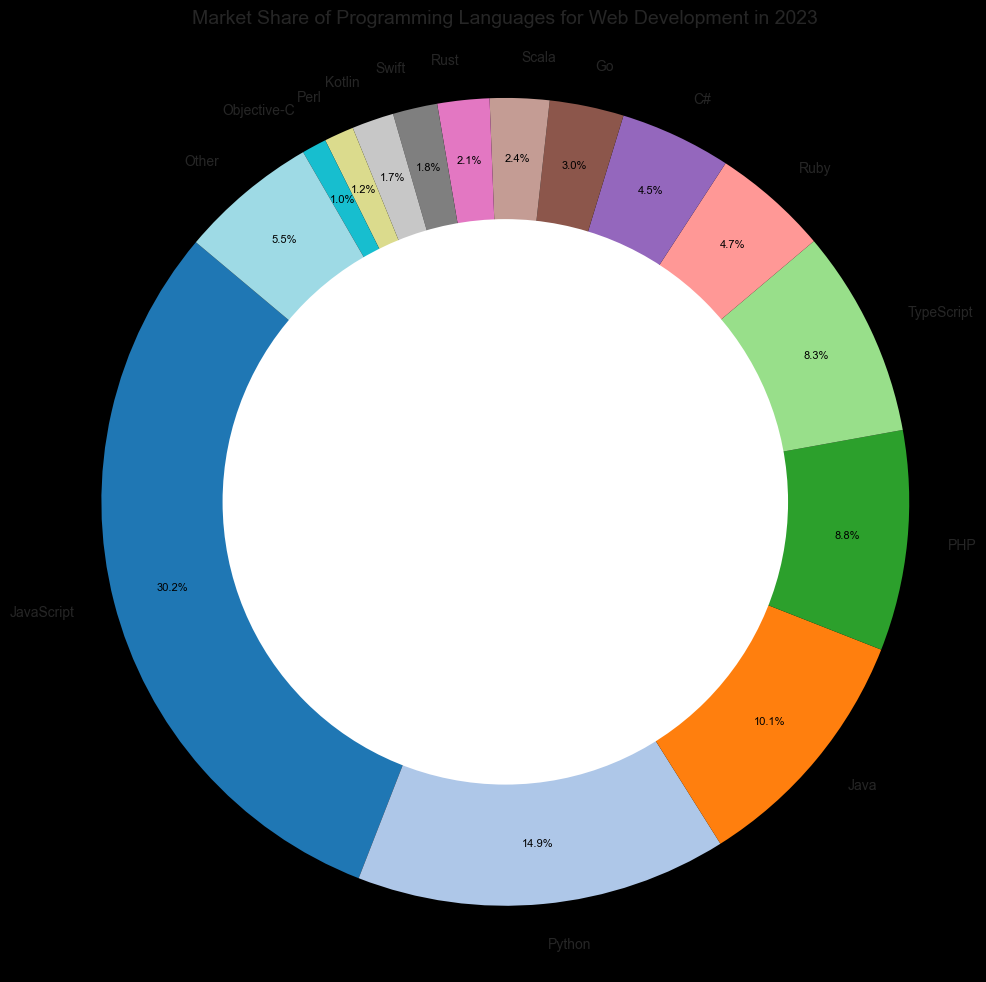What's the total market share of the top three programming languages? The top three programming languages by market share are JavaScript, Python, and Java. Summing up their market shares: 30.5% (JavaScript) + 15.0% (Python) + 10.2% (Java) = 55.7%.
Answer: 55.7% Which language has a higher market share, PHP or TypeScript? By observing the chart, the market share of PHP is 8.9% and TypeScript is 8.4%. Comparing these two values, PHP has a higher market share.
Answer: PHP How much more market share does JavaScript have compared to Python? The market share of JavaScript is 30.5% and Python is 15.0%. Subtracting Python's share from JavaScript's share: 30.5% - 15.0% = 15.5%.
Answer: 15.5% What is the combined market share of Ruby, C#, and Go? The market shares are: Ruby with 4.7%, C# with 4.5%, and Go with 3.0%. Summing these values: 4.7% + 4.5% + 3.0% = 12.2%.
Answer: 12.2% Which language has the smallest market share, and what is it? By observing the sizes on the ring chart, Objective-C has the smallest market share, which is 1.0%.
Answer: Objective-C, 1.0% Is the market share of Python greater than the combined market share of Rust and Kotlin? The market share of Python is 15.0%. The combined market share of Rust (2.1%) and Kotlin (1.7%) is 2.1% + 1.7% = 3.8%. Comparing these, Python's market share is indeed greater.
Answer: Yes What color representation is associated with Perl in the chart? By examining the colors used in the ring chart, the color associated with Perl should be noted. (Assuming the viewer of the ring chart can see and identify this color directly.)
Answer: (Color associated with Perl in chart) If you sum the market shares of all languages except for "Other", what is the resulting market share? Adding the market shares of all languages except "Other": 30.5% (JavaScript) + 15.0% (Python) + 10.2% (Java) + 8.9% (PHP) + 8.4% (TypeScript) + 4.7% (Ruby) + 4.5% (C#) + 3.0% (Go) + 2.4% (Scala) + 2.1% (Rust) + 1.8% (Swift) + 1.7% (Kotlin) + 1.2% (Perl) + 1.0% (Objective-C) = 95.4%.
Answer: 95.4% How does the visual length of the Python segment compare to the segments of Ruby and C# combined? Visually, the segment for Python is more than twice as long as each segment for Ruby and C#, indicating it is longer than the combined length of Ruby and C#.
Answer: Longer 